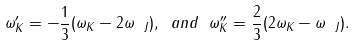<formula> <loc_0><loc_0><loc_500><loc_500>\omega _ { K } ^ { \prime } = - \frac { 1 } { 3 } ( \omega _ { K } - 2 \omega _ { \ J } ) , \ a n d \ \omega _ { K } ^ { \prime \prime } = \frac { 2 } { 3 } ( 2 \omega _ { K } - \omega _ { \ J } ) .</formula> 